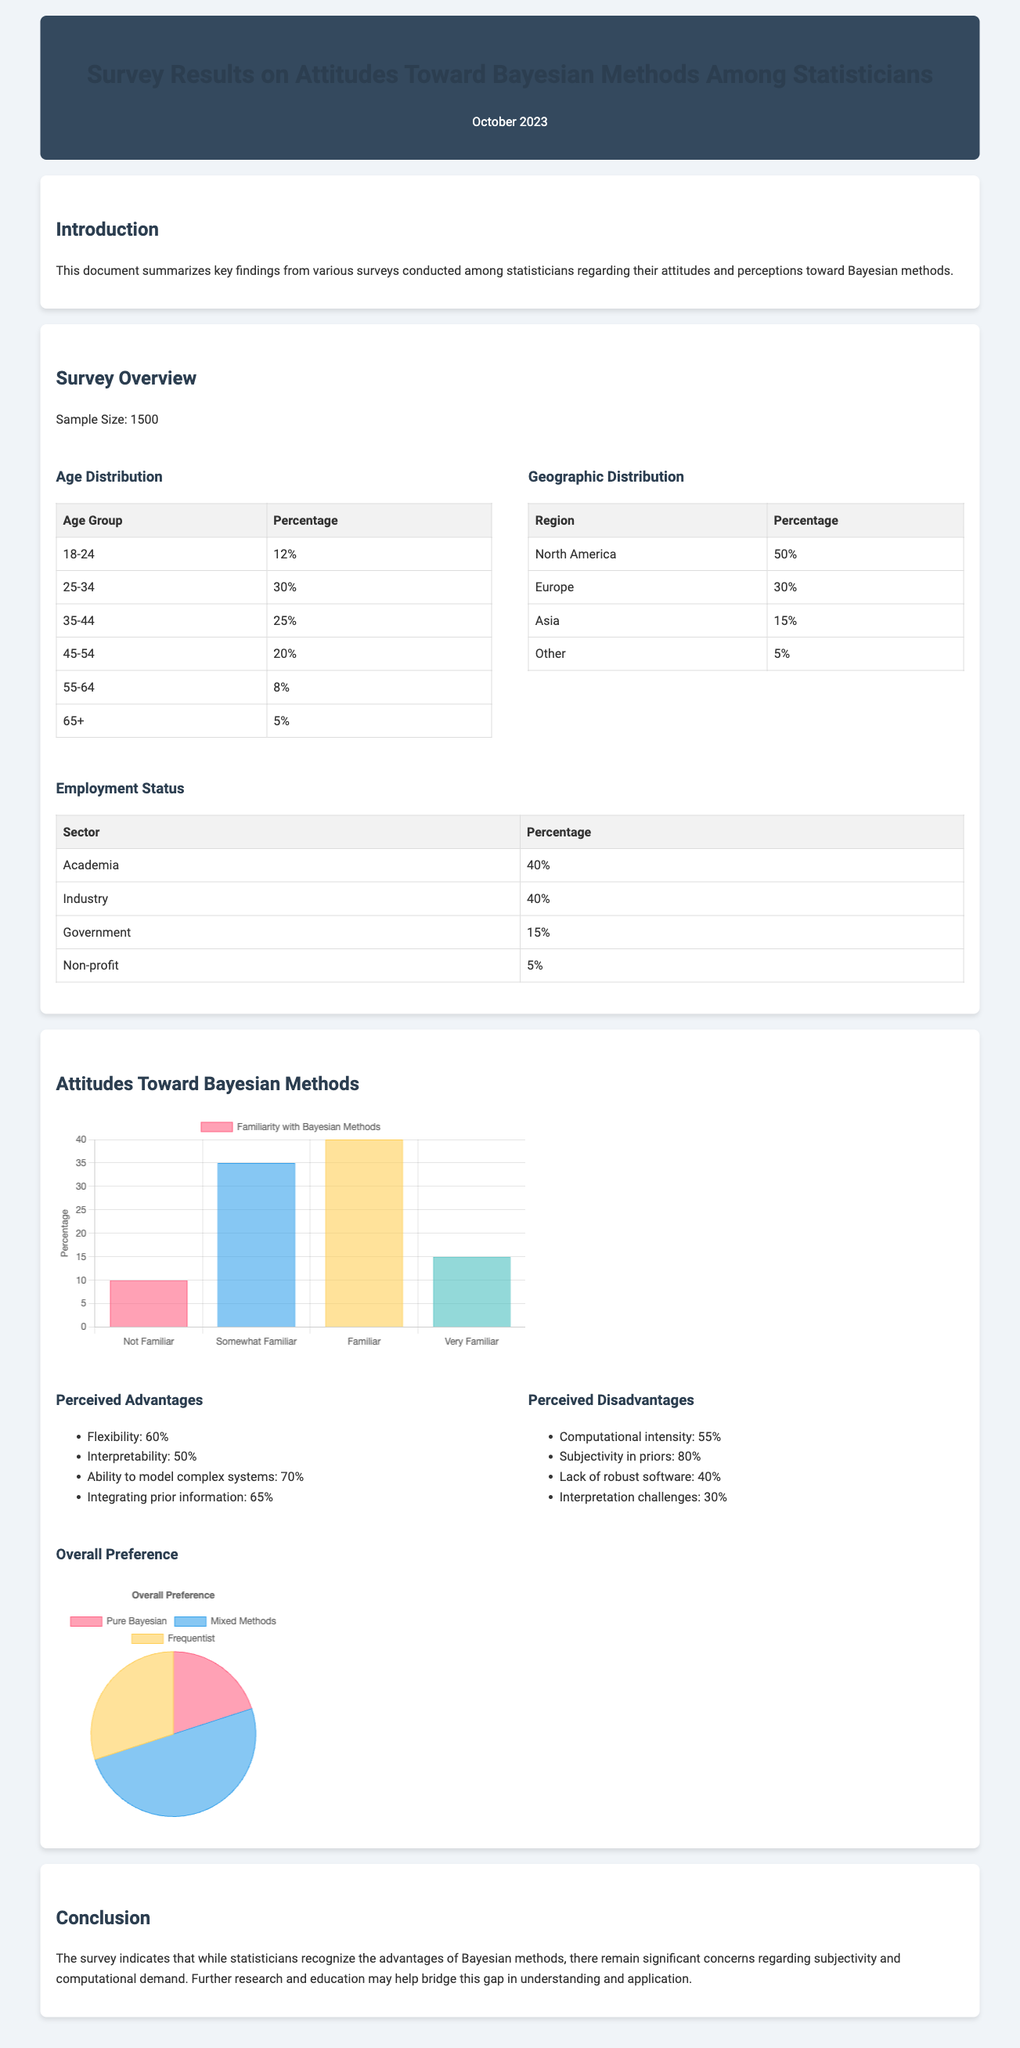What is the sample size of the survey? The sample size of the survey is explicitly stated in the document under the survey overview section.
Answer: 1500 What percentage of respondents are from North America? The geographic distribution table provides specific percentages for each region, including North America.
Answer: 50% What is the percentage of respondents who consider Bayesian methods to have flexibility as an advantage? The perceived advantages section lists the percentage of respondents who consider flexibility as an advantage.
Answer: 60% How many age groups are represented in the survey results? The age distribution table outlines various age groups, indicating the total count of unique groups present.
Answer: 6 What is the main perceived disadvantage of Bayesian methods according to the survey? The perceived disadvantages section lists several disadvantages, highlighting the one with the highest percentage of concern.
Answer: Subjectivity in priors What is the preference for mixed methods among respondents? The preference chart illustrates the distribution of preferences among different methods, including mixed methods, with a specific value indicated.
Answer: 50% Is the majority of respondents from academia or industry? The employment status table shows the percentages for both academia and industry, allowing for a comparison to determine the majority sector.
Answer: Equal (40%) What percentage of respondents are very familiar with Bayesian methods? The familiarity chart provides percentages for familiarity levels, specifically highlighting the percentage of those very familiar with Bayesian methods.
Answer: 15% What is the title of this document? The title is prominently featured at the top of the document as part of the header section.
Answer: Survey Results on Attitudes Toward Bayesian Methods Among Statisticians 